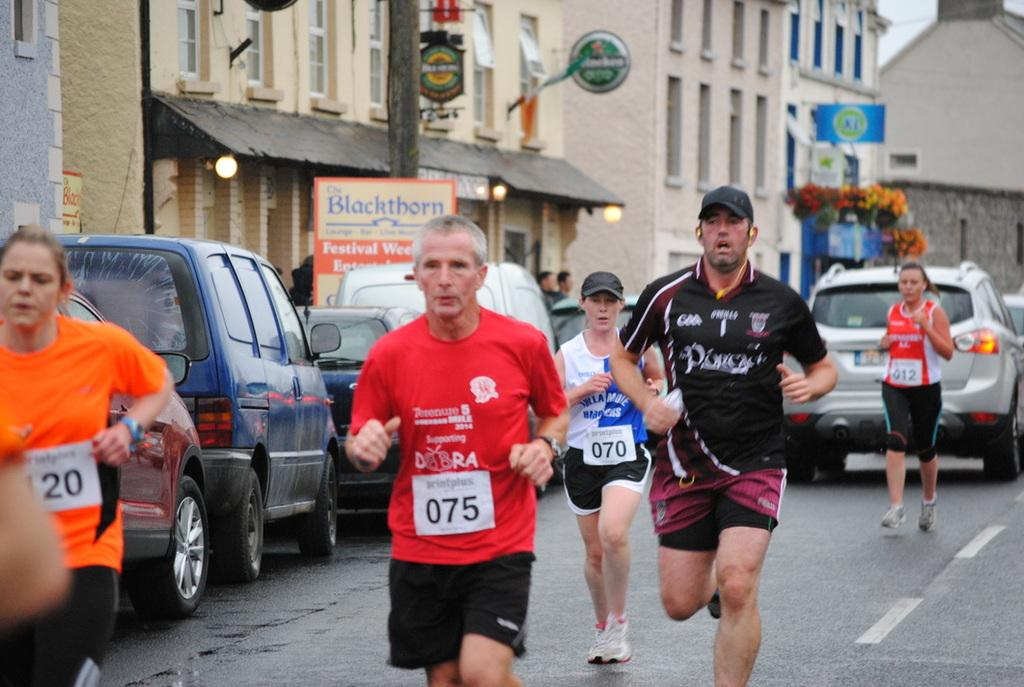<image>
Offer a succinct explanation of the picture presented. Several runners run on pavement past a building with a sign for The Blackthorn. 